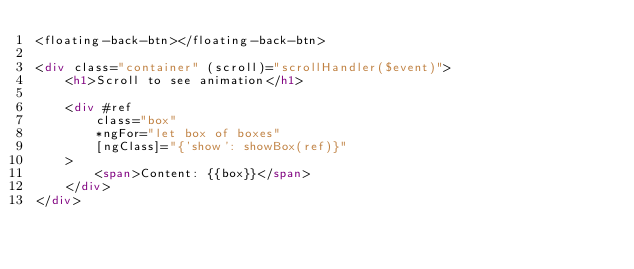<code> <loc_0><loc_0><loc_500><loc_500><_HTML_><floating-back-btn></floating-back-btn>

<div class="container" (scroll)="scrollHandler($event)">
    <h1>Scroll to see animation</h1>

    <div #ref
        class="box"
        *ngFor="let box of boxes"
        [ngClass]="{'show': showBox(ref)}"
    >
        <span>Content: {{box}}</span>
    </div>
</div></code> 